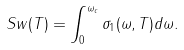<formula> <loc_0><loc_0><loc_500><loc_500>S w ( T ) = \int _ { 0 } ^ { \omega _ { c } } \sigma _ { 1 } ( \omega , T ) d \omega .</formula> 